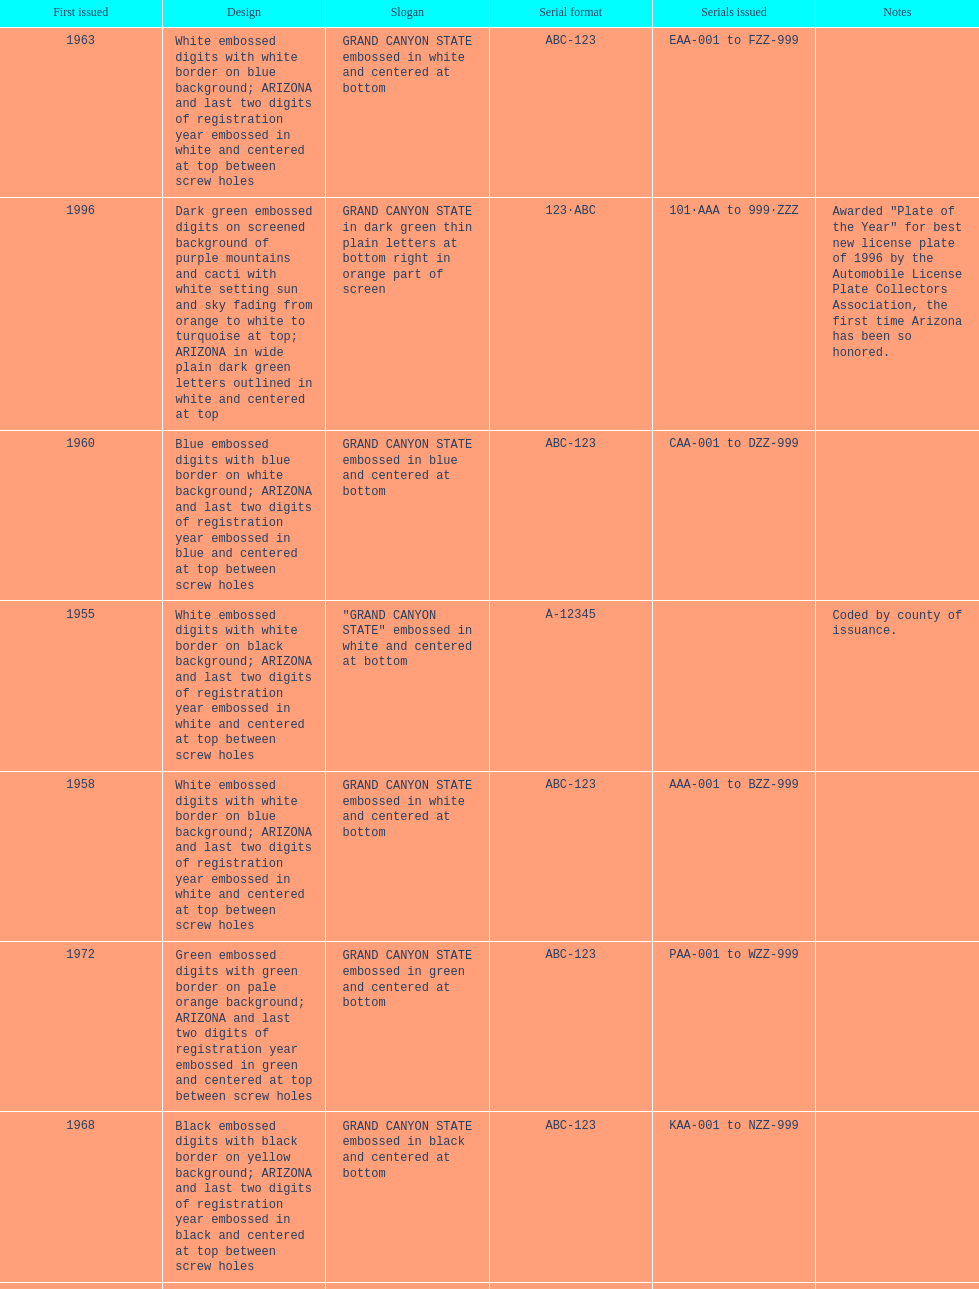Which year featured the license plate with the least characters? 1955. 